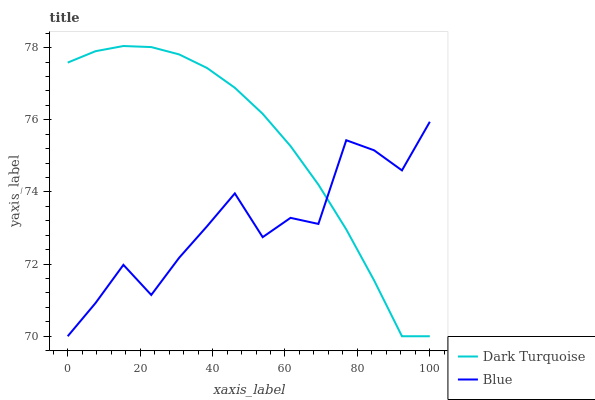Does Dark Turquoise have the minimum area under the curve?
Answer yes or no. No. Is Dark Turquoise the roughest?
Answer yes or no. No. 